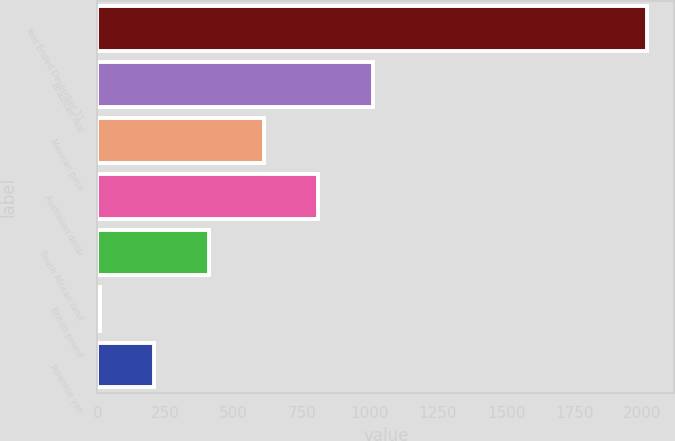Convert chart. <chart><loc_0><loc_0><loc_500><loc_500><bar_chart><fcel>Year Ended December 31<fcel>Brazilian real<fcel>Mexican peso<fcel>Australian dollar<fcel>South African rand<fcel>British pound<fcel>Japanese yen<nl><fcel>2015<fcel>1011.5<fcel>610.1<fcel>810.8<fcel>409.4<fcel>8<fcel>208.7<nl></chart> 